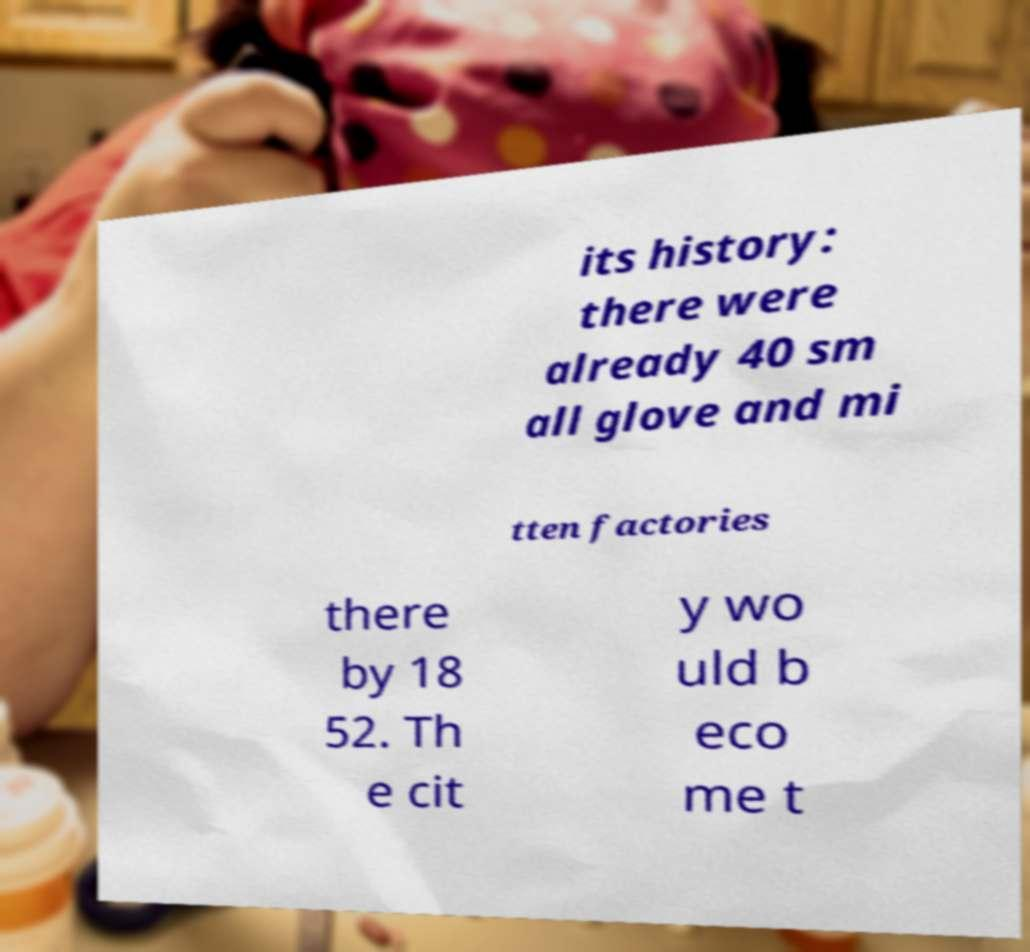There's text embedded in this image that I need extracted. Can you transcribe it verbatim? its history: there were already 40 sm all glove and mi tten factories there by 18 52. Th e cit y wo uld b eco me t 